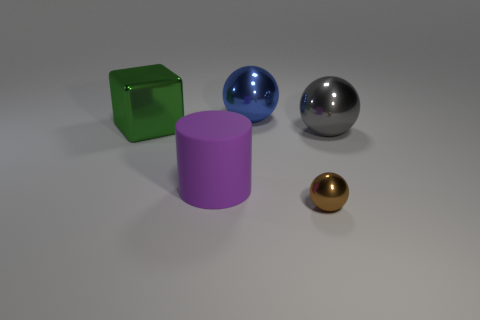Is there a green shiny object of the same shape as the purple thing?
Offer a terse response. No. Is there a blue shiny ball in front of the big shiny sphere that is behind the shiny thing to the left of the purple cylinder?
Give a very brief answer. No. Is the number of green metallic cubes that are on the left side of the blue ball greater than the number of big gray objects behind the metallic cube?
Provide a succinct answer. Yes. There is a gray object that is the same size as the purple cylinder; what is its material?
Ensure brevity in your answer.  Metal. How many small things are yellow balls or green blocks?
Your response must be concise. 0. Is the large gray object the same shape as the blue thing?
Offer a very short reply. Yes. What number of big things are both on the right side of the purple object and on the left side of the big gray ball?
Ensure brevity in your answer.  1. Are there any other things of the same color as the large metallic cube?
Your answer should be very brief. No. What shape is the green thing that is the same material as the large blue ball?
Provide a short and direct response. Cube. Do the green metal object and the rubber cylinder have the same size?
Your response must be concise. Yes. 